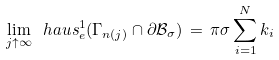Convert formula to latex. <formula><loc_0><loc_0><loc_500><loc_500>\lim _ { j \uparrow \infty } \ h a u s ^ { 1 } _ { e } ( \Gamma _ { n ( j ) } \cap \partial \mathcal { B } _ { \sigma } ) \, = \, \pi \sigma \sum _ { i = 1 } ^ { N } k _ { i }</formula> 